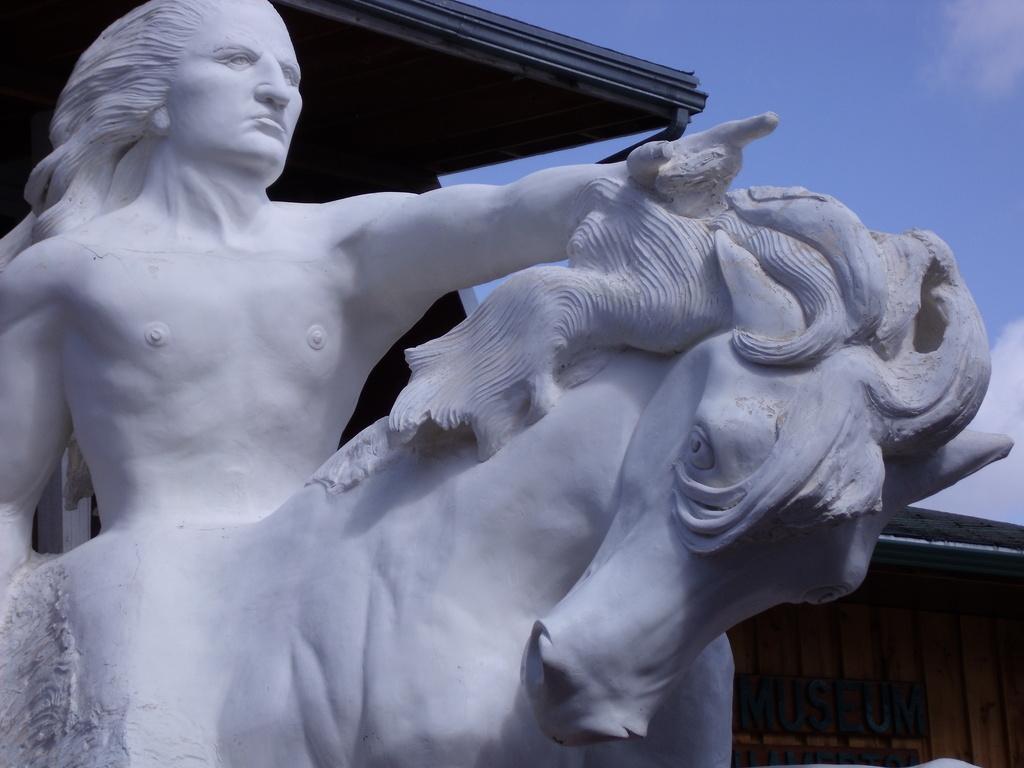Could you give a brief overview of what you see in this image? In this image we can see statue, name board and sky with clouds. 